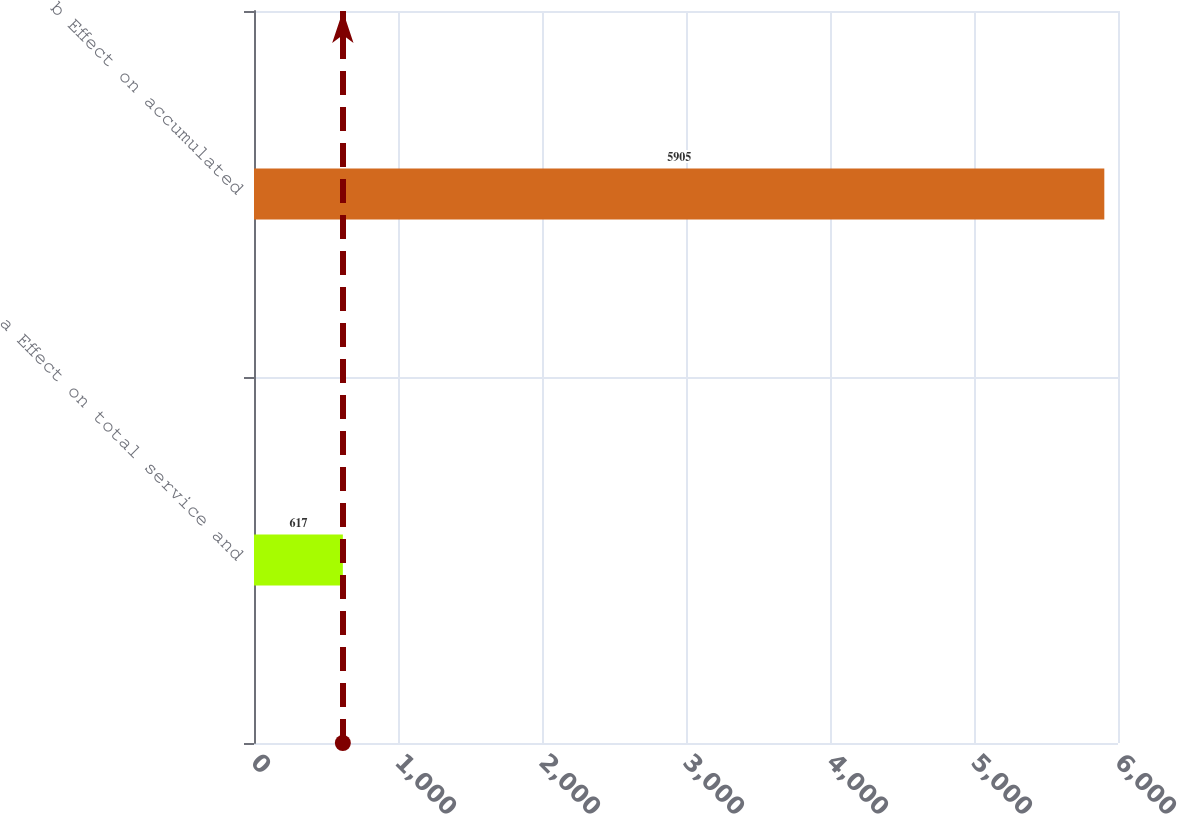<chart> <loc_0><loc_0><loc_500><loc_500><bar_chart><fcel>a Effect on total service and<fcel>b Effect on accumulated<nl><fcel>617<fcel>5905<nl></chart> 